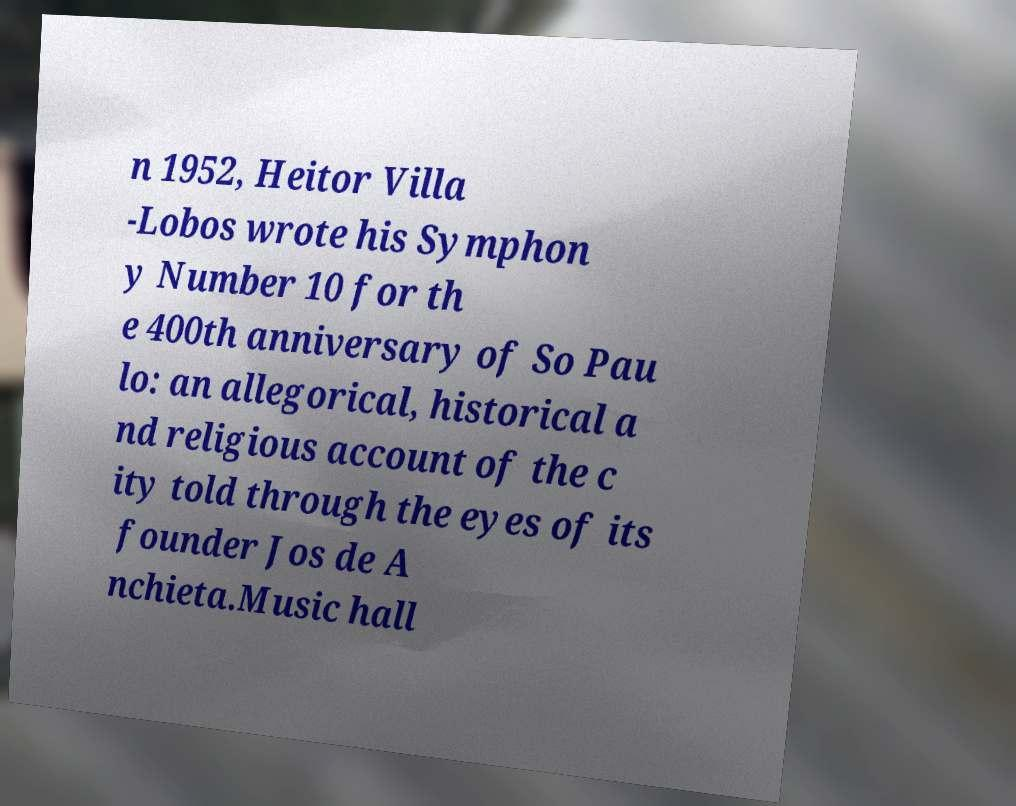Could you extract and type out the text from this image? n 1952, Heitor Villa -Lobos wrote his Symphon y Number 10 for th e 400th anniversary of So Pau lo: an allegorical, historical a nd religious account of the c ity told through the eyes of its founder Jos de A nchieta.Music hall 